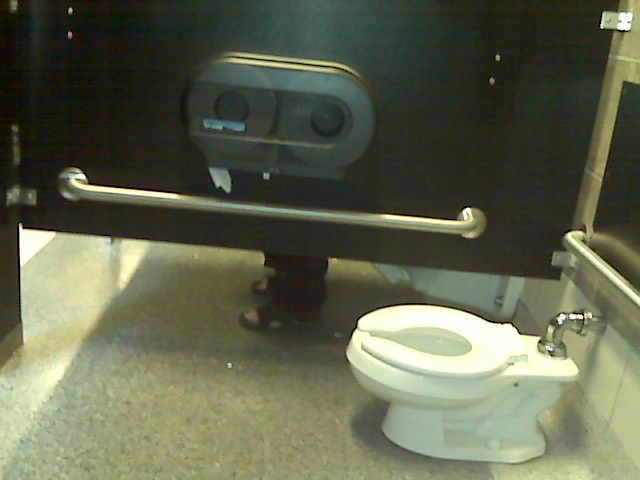Describe the objects in this image and their specific colors. I can see toilet in black, darkgray, and beige tones, people in black, darkgreen, and gray tones, and toilet in black and gray tones in this image. 